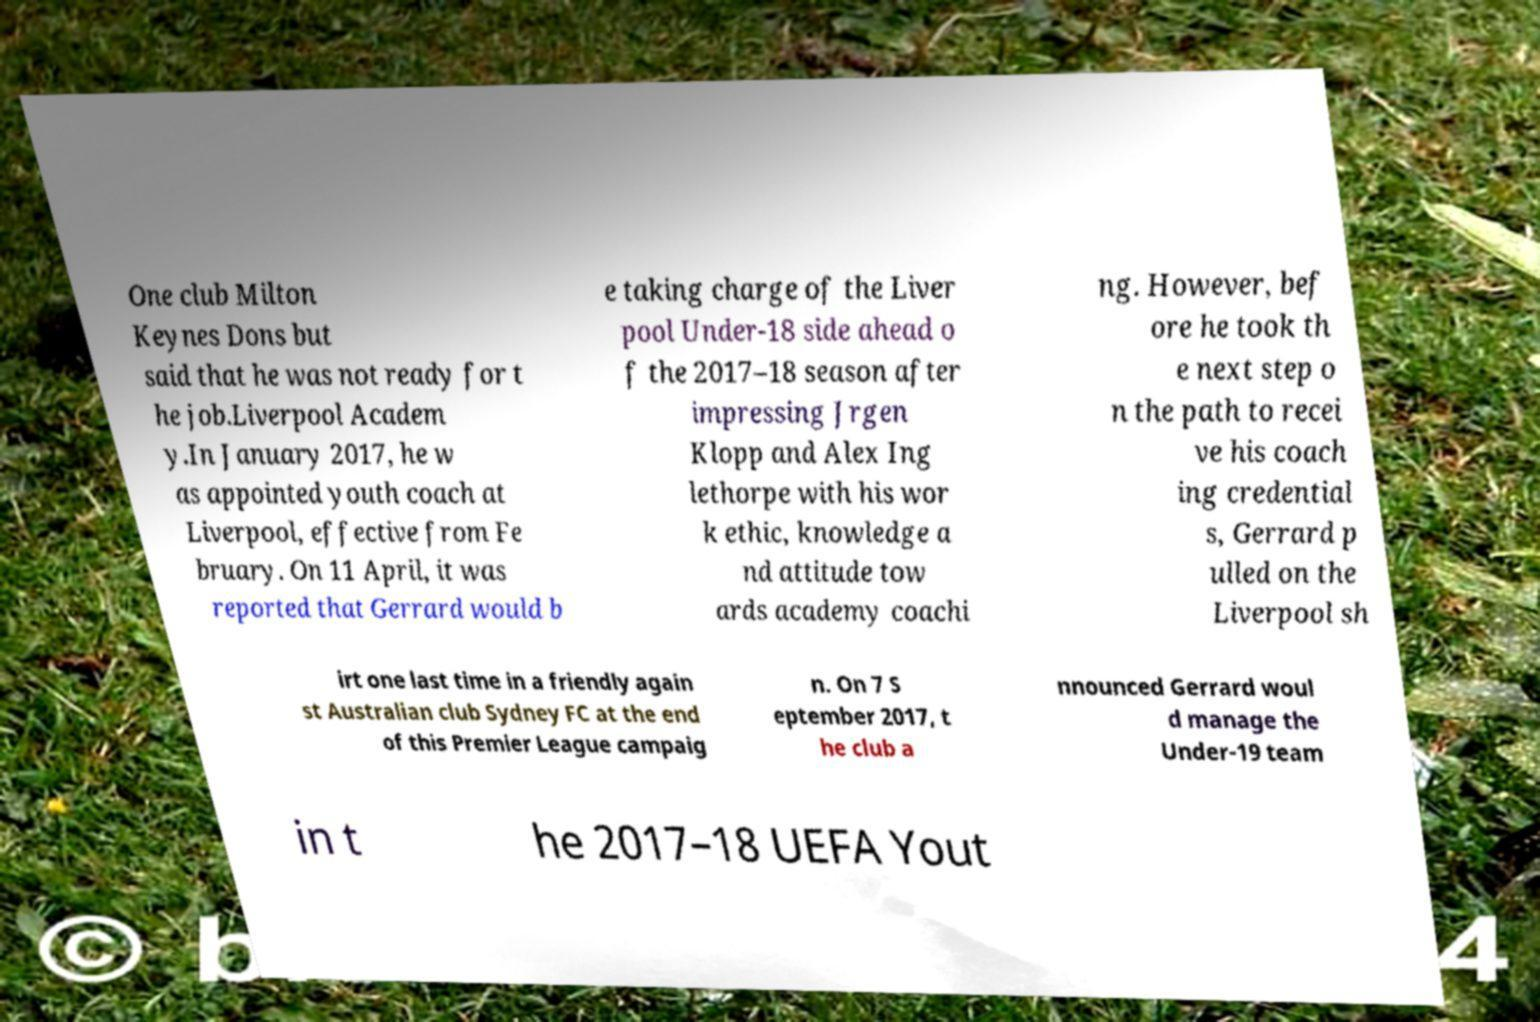Please identify and transcribe the text found in this image. One club Milton Keynes Dons but said that he was not ready for t he job.Liverpool Academ y.In January 2017, he w as appointed youth coach at Liverpool, effective from Fe bruary. On 11 April, it was reported that Gerrard would b e taking charge of the Liver pool Under-18 side ahead o f the 2017–18 season after impressing Jrgen Klopp and Alex Ing lethorpe with his wor k ethic, knowledge a nd attitude tow ards academy coachi ng. However, bef ore he took th e next step o n the path to recei ve his coach ing credential s, Gerrard p ulled on the Liverpool sh irt one last time in a friendly again st Australian club Sydney FC at the end of this Premier League campaig n. On 7 S eptember 2017, t he club a nnounced Gerrard woul d manage the Under-19 team in t he 2017–18 UEFA Yout 